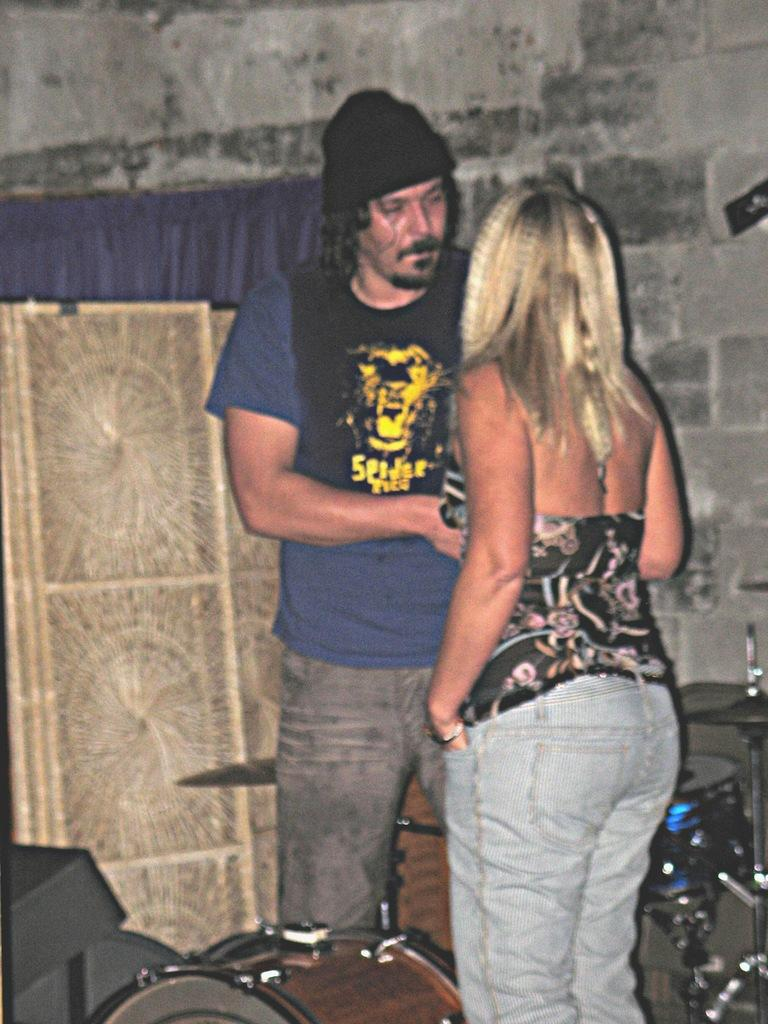How many people are present in the image? There are two people standing in the image. What is located at the bottom of the image? There is a musical instrument at the bottom of the image. What can be seen in the background of the image? There is a wall visible in the background of the image, along with some unspecified objects. Are there any ants crawling on the musical instrument in the image? There is no indication of ants in the image; the focus is on the two people and the musical instrument. 